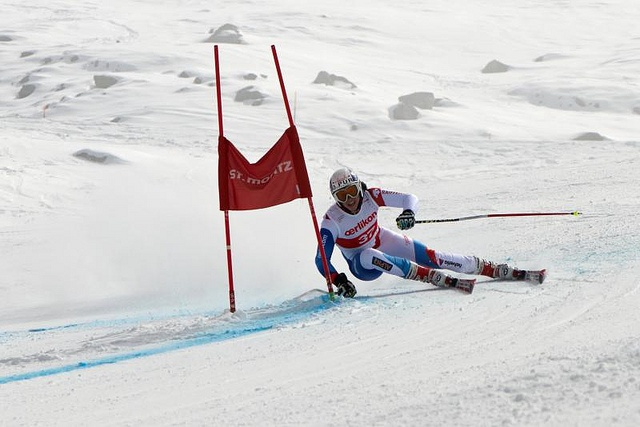Describe the objects in this image and their specific colors. I can see people in white, darkgray, gray, and black tones and skis in white, gray, black, lightgray, and darkgray tones in this image. 